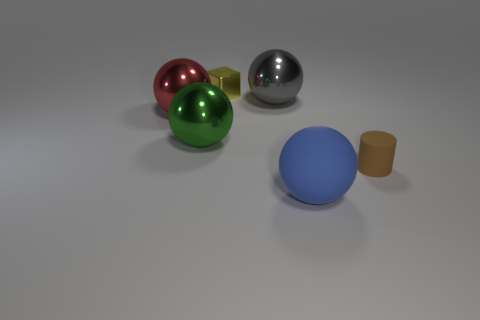How many blue cylinders are the same size as the brown cylinder?
Ensure brevity in your answer.  0. Are there fewer yellow metallic objects that are in front of the matte cylinder than large red matte things?
Offer a terse response. No. What is the size of the matte object that is behind the big sphere in front of the small matte thing?
Give a very brief answer. Small. How many objects are big gray rubber cubes or tiny yellow things?
Give a very brief answer. 1. Is there another tiny cylinder of the same color as the tiny matte cylinder?
Give a very brief answer. No. Is the number of small gray rubber objects less than the number of things?
Make the answer very short. Yes. How many objects are yellow cubes or large objects that are on the right side of the large red thing?
Ensure brevity in your answer.  4. Are there any tiny green objects made of the same material as the yellow block?
Ensure brevity in your answer.  No. There is a blue sphere that is the same size as the red shiny sphere; what material is it?
Your answer should be compact. Rubber. What is the material of the large red thing behind the large ball that is in front of the big green sphere?
Offer a very short reply. Metal. 